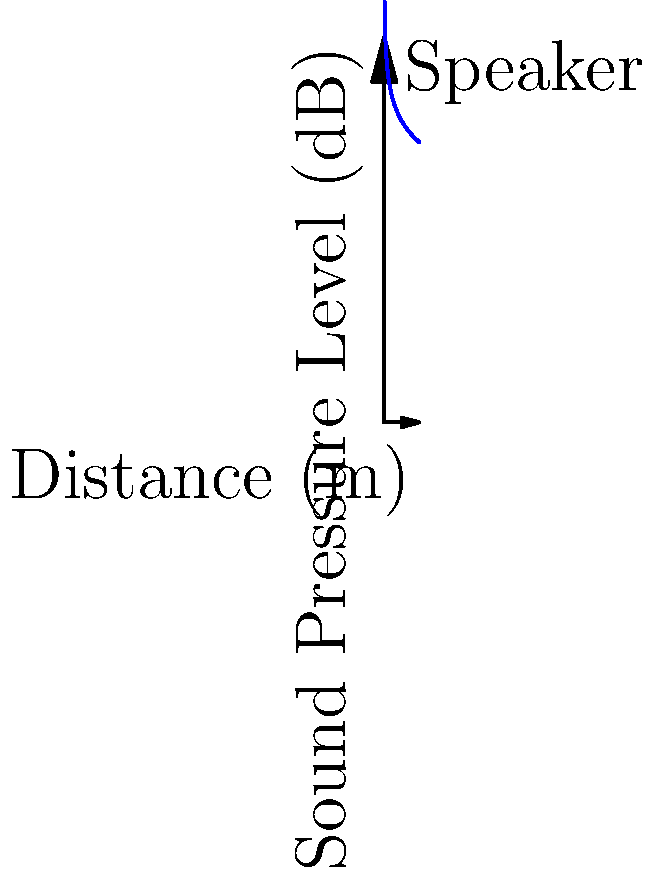A speaker at a live performance emits sound at 100 dB when measured at 1 meter. Assuming spherical spreading in an ideal environment, at what distance from the speaker would the sound pressure level decrease to 70 dB? To solve this problem, we'll use the inverse square law for sound intensity and the relationship between sound intensity and sound pressure level.

1) The inverse square law states that sound intensity is inversely proportional to the square of the distance:

   $I_2 = I_1 \cdot (\frac{r_1}{r_2})^2$

2) The relationship between sound pressure level (SPL) and intensity is:

   $SPL = 10 \log_{10}(\frac{I}{I_0})$

3) We can express the change in SPL as:

   $SPL_2 - SPL_1 = 10 \log_{10}(\frac{I_2}{I_1})$

4) Substituting the inverse square law:

   $SPL_2 - SPL_1 = 10 \log_{10}((\frac{r_1}{r_2})^2) = 20 \log_{10}(\frac{r_1}{r_2})$

5) Rearranging:

   $\frac{r_2}{r_1} = 10^{\frac{SPL_1 - SPL_2}{20}}$

6) Given:
   $SPL_1 = 100$ dB at $r_1 = 1$ m
   $SPL_2 = 70$ dB at $r_2 = ?$ m

7) Plugging in the values:

   $\frac{r_2}{1} = 10^{\frac{100 - 70}{20}} = 10^{\frac{30}{20}} = 10^{1.5} \approx 31.62$

8) Therefore, $r_2 \approx 31.62$ meters.
Answer: 31.62 meters 